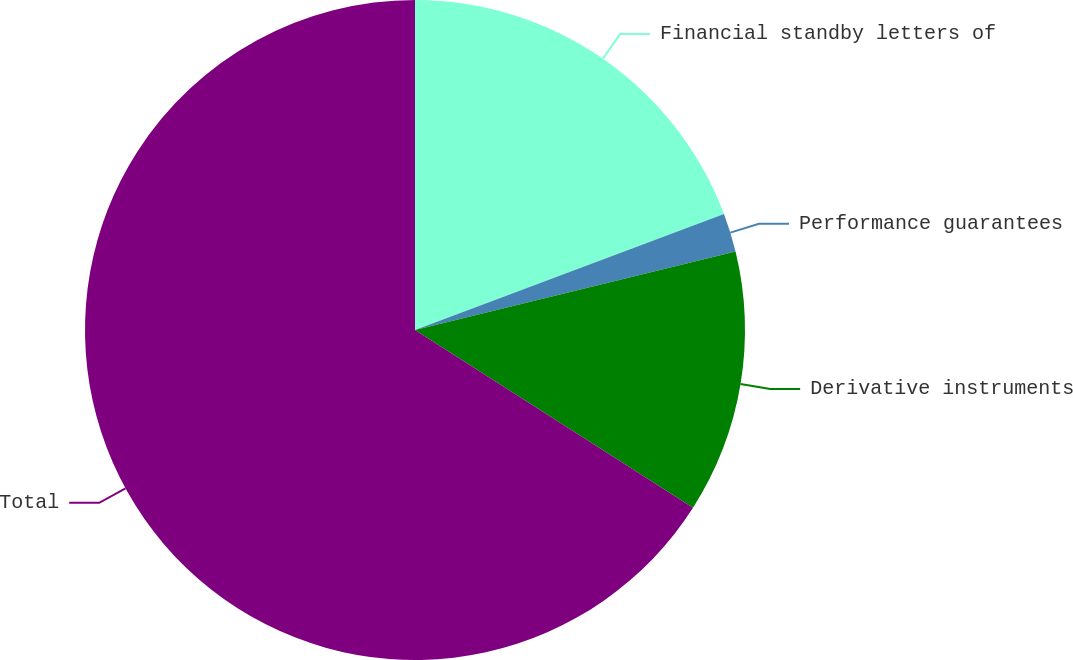Convert chart. <chart><loc_0><loc_0><loc_500><loc_500><pie_chart><fcel>Financial standby letters of<fcel>Performance guarantees<fcel>Derivative instruments<fcel>Total<nl><fcel>19.29%<fcel>1.89%<fcel>12.88%<fcel>65.95%<nl></chart> 